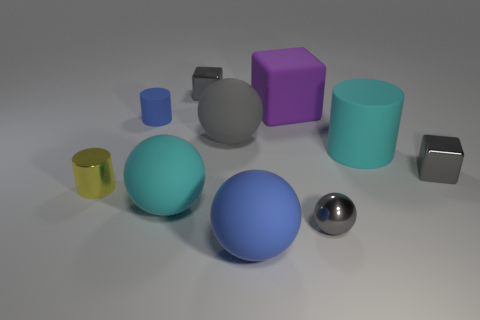Is the number of large rubber cubes that are in front of the big block less than the number of metal things to the left of the small yellow metallic cylinder?
Offer a very short reply. No. There is a tiny gray object behind the small gray cube that is in front of the small gray object that is to the left of the large gray object; what is its material?
Provide a succinct answer. Metal. There is a gray metallic object that is both behind the cyan rubber ball and in front of the large cube; how big is it?
Your response must be concise. Small. What number of spheres are small cyan rubber things or large gray things?
Your response must be concise. 1. There is a cube that is the same size as the cyan matte cylinder; what is its color?
Give a very brief answer. Purple. Is there any other thing that has the same shape as the big blue rubber object?
Your answer should be very brief. Yes. What color is the metallic object that is the same shape as the large gray matte thing?
Give a very brief answer. Gray. What number of things are either blue spheres or blocks on the right side of the gray rubber ball?
Offer a very short reply. 3. Is the number of small metallic spheres that are in front of the large blue matte ball less than the number of tiny yellow cylinders?
Keep it short and to the point. Yes. There is a cyan matte cylinder on the left side of the gray block in front of the big sphere that is behind the cyan matte ball; what size is it?
Ensure brevity in your answer.  Large. 